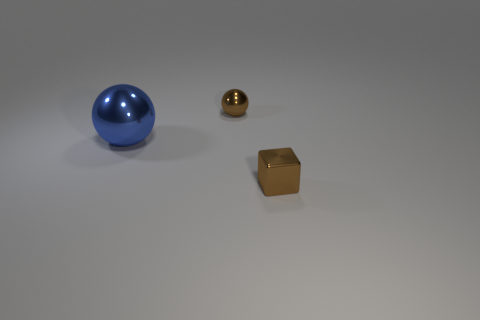Add 3 large spheres. How many objects exist? 6 Subtract all balls. How many objects are left? 1 Subtract all tiny red cylinders. Subtract all small brown objects. How many objects are left? 1 Add 2 big metal objects. How many big metal objects are left? 3 Add 2 metallic blocks. How many metallic blocks exist? 3 Subtract 1 blue balls. How many objects are left? 2 